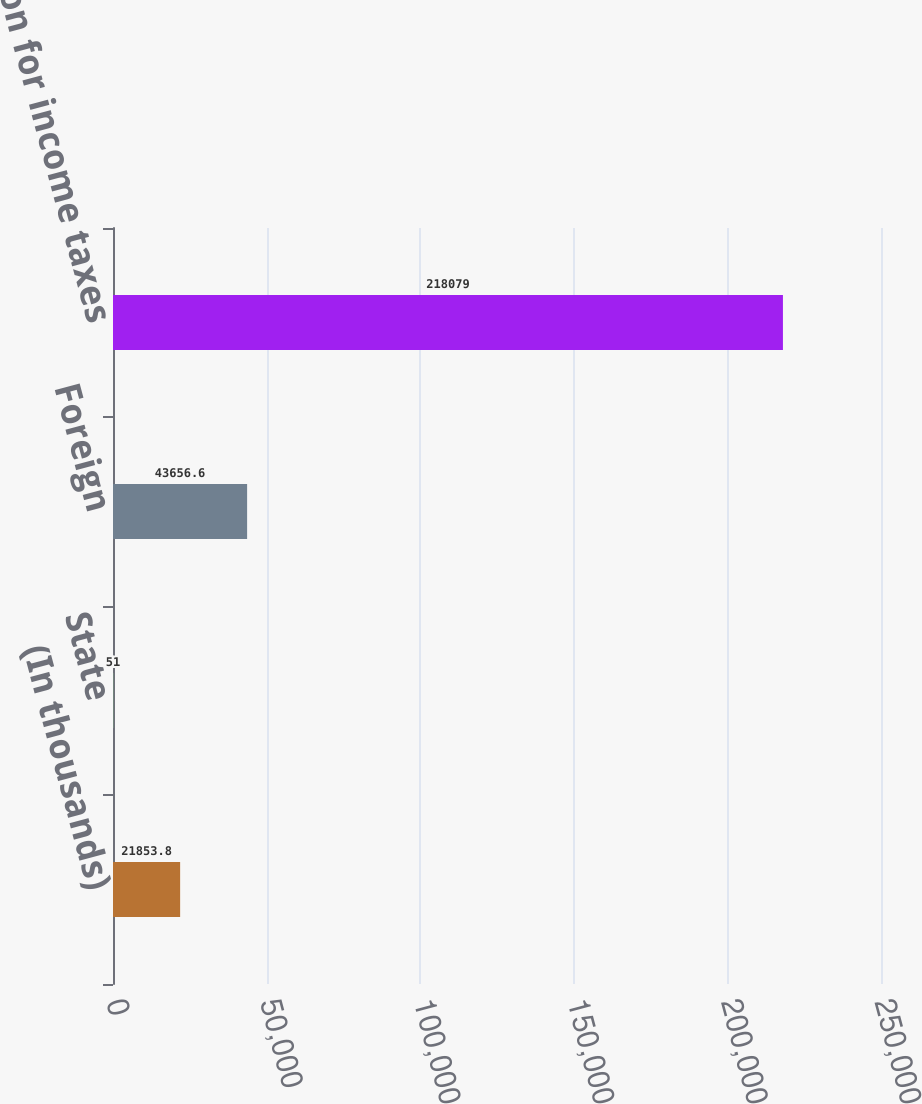Convert chart to OTSL. <chart><loc_0><loc_0><loc_500><loc_500><bar_chart><fcel>(In thousands)<fcel>State<fcel>Foreign<fcel>Provision for income taxes<nl><fcel>21853.8<fcel>51<fcel>43656.6<fcel>218079<nl></chart> 